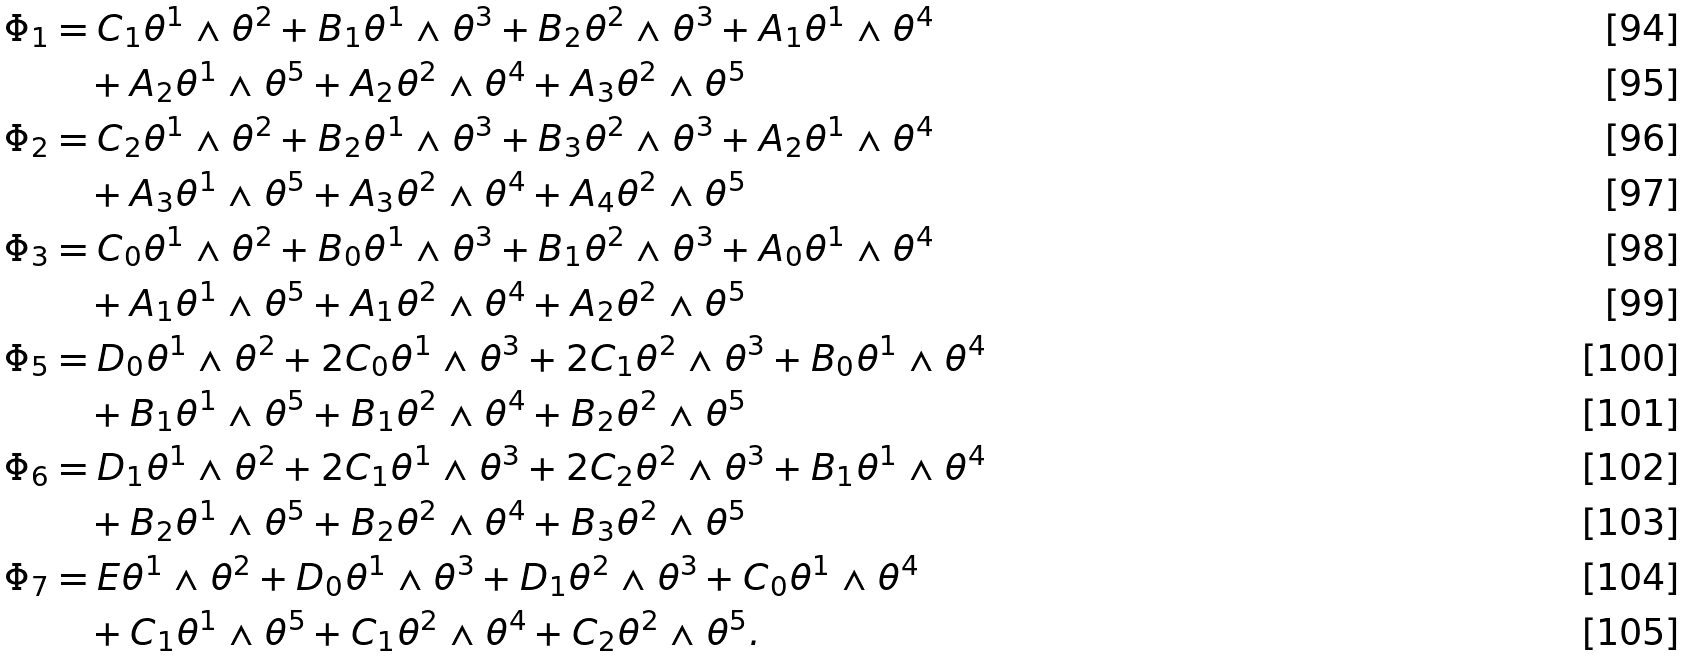<formula> <loc_0><loc_0><loc_500><loc_500>\Phi _ { 1 } & = C _ { 1 } \theta ^ { 1 } \wedge \theta ^ { 2 } + B _ { 1 } \theta ^ { 1 } \wedge \theta ^ { 3 } + B _ { 2 } \theta ^ { 2 } \wedge \theta ^ { 3 } + A _ { 1 } \theta ^ { 1 } \wedge \theta ^ { 4 } \\ & \quad + A _ { 2 } \theta ^ { 1 } \wedge \theta ^ { 5 } + A _ { 2 } \theta ^ { 2 } \wedge \theta ^ { 4 } + A _ { 3 } \theta ^ { 2 } \wedge \theta ^ { 5 } \\ \Phi _ { 2 } & = C _ { 2 } \theta ^ { 1 } \wedge \theta ^ { 2 } + B _ { 2 } \theta ^ { 1 } \wedge \theta ^ { 3 } + B _ { 3 } \theta ^ { 2 } \wedge \theta ^ { 3 } + A _ { 2 } \theta ^ { 1 } \wedge \theta ^ { 4 } \\ & \quad + A _ { 3 } \theta ^ { 1 } \wedge \theta ^ { 5 } + A _ { 3 } \theta ^ { 2 } \wedge \theta ^ { 4 } + A _ { 4 } \theta ^ { 2 } \wedge \theta ^ { 5 } \\ \Phi _ { 3 } & = C _ { 0 } \theta ^ { 1 } \wedge \theta ^ { 2 } + B _ { 0 } \theta ^ { 1 } \wedge \theta ^ { 3 } + B _ { 1 } \theta ^ { 2 } \wedge \theta ^ { 3 } + A _ { 0 } \theta ^ { 1 } \wedge \theta ^ { 4 } \\ & \quad + A _ { 1 } \theta ^ { 1 } \wedge \theta ^ { 5 } + A _ { 1 } \theta ^ { 2 } \wedge \theta ^ { 4 } + A _ { 2 } \theta ^ { 2 } \wedge \theta ^ { 5 } \\ \Phi _ { 5 } & = D _ { 0 } \theta ^ { 1 } \wedge \theta ^ { 2 } + 2 C _ { 0 } \theta ^ { 1 } \wedge \theta ^ { 3 } + 2 C _ { 1 } \theta ^ { 2 } \wedge \theta ^ { 3 } + B _ { 0 } \theta ^ { 1 } \wedge \theta ^ { 4 } \\ & \quad + B _ { 1 } \theta ^ { 1 } \wedge \theta ^ { 5 } + B _ { 1 } \theta ^ { 2 } \wedge \theta ^ { 4 } + B _ { 2 } \theta ^ { 2 } \wedge \theta ^ { 5 } \\ \Phi _ { 6 } & = D _ { 1 } \theta ^ { 1 } \wedge \theta ^ { 2 } + 2 C _ { 1 } \theta ^ { 1 } \wedge \theta ^ { 3 } + 2 C _ { 2 } \theta ^ { 2 } \wedge \theta ^ { 3 } + B _ { 1 } \theta ^ { 1 } \wedge \theta ^ { 4 } \\ & \quad + B _ { 2 } \theta ^ { 1 } \wedge \theta ^ { 5 } + B _ { 2 } \theta ^ { 2 } \wedge \theta ^ { 4 } + B _ { 3 } \theta ^ { 2 } \wedge \theta ^ { 5 } \\ \Phi _ { 7 } & = E \theta ^ { 1 } \wedge \theta ^ { 2 } + D _ { 0 } \theta ^ { 1 } \wedge \theta ^ { 3 } + D _ { 1 } \theta ^ { 2 } \wedge \theta ^ { 3 } + C _ { 0 } \theta ^ { 1 } \wedge \theta ^ { 4 } \\ & \quad + C _ { 1 } \theta ^ { 1 } \wedge \theta ^ { 5 } + C _ { 1 } \theta ^ { 2 } \wedge \theta ^ { 4 } + C _ { 2 } \theta ^ { 2 } \wedge \theta ^ { 5 } .</formula> 